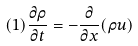<formula> <loc_0><loc_0><loc_500><loc_500>( 1 ) \frac { \partial \rho } { \partial t } = - \frac { \partial } { \partial x } ( \rho u )</formula> 